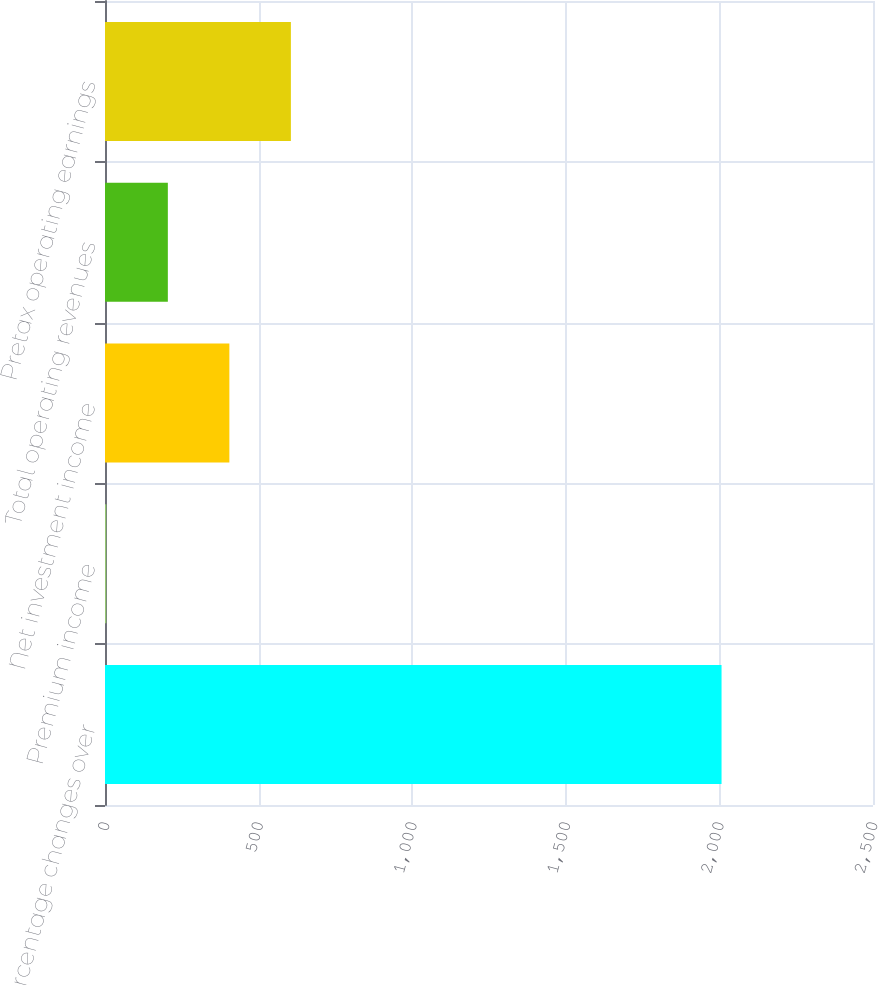Convert chart. <chart><loc_0><loc_0><loc_500><loc_500><bar_chart><fcel>Percentage changes over<fcel>Premium income<fcel>Net investment income<fcel>Total operating revenues<fcel>Pretax operating earnings<nl><fcel>2007<fcel>4.3<fcel>404.84<fcel>204.57<fcel>605.11<nl></chart> 